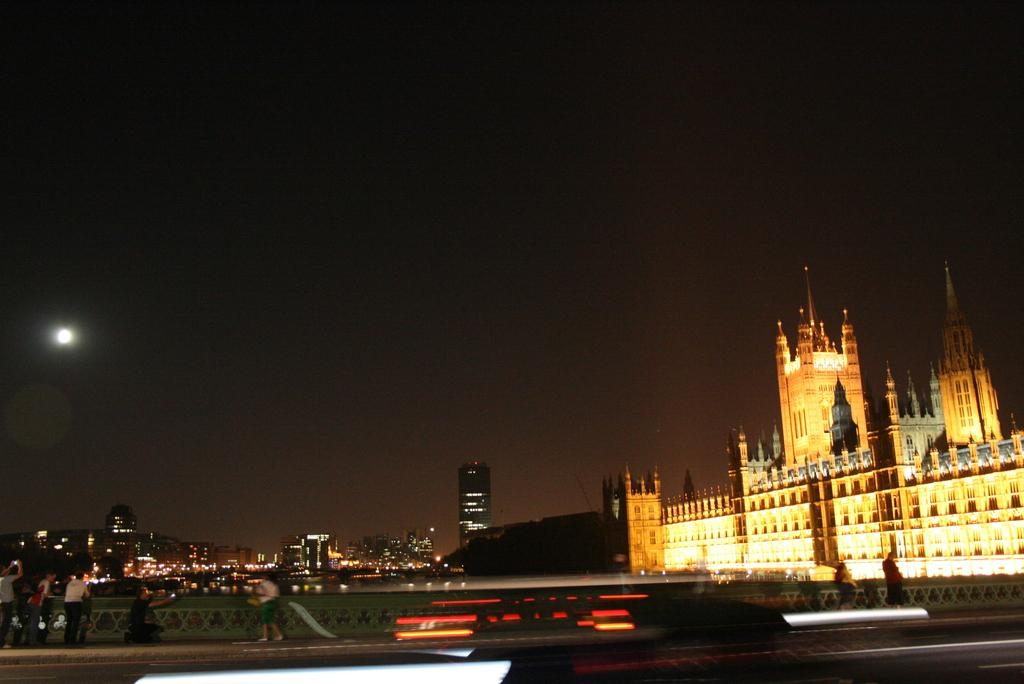What can be seen in the center of the image? The sky is visible in the center of the image. What celestial body is present in the image? The moon is present in the image. What type of structures can be seen in the image? There are buildings and towers in the image. What is the source of illumination in the image? Lights are visible in the image. What type of barrier is present in the image? There are fences in the image. What are the people in the image doing? There are people standing in the image, and some of them are holding objects. What other objects can be seen in the image? There are other objects present in the image. Can you tell me how many bananas are being held by the people in the image? There is no mention of bananas in the image; people are holding objects, but their nature is not specified. What type of shock can be seen affecting the people in the image? There is no indication of any shock or disturbance affecting the people in the image. 